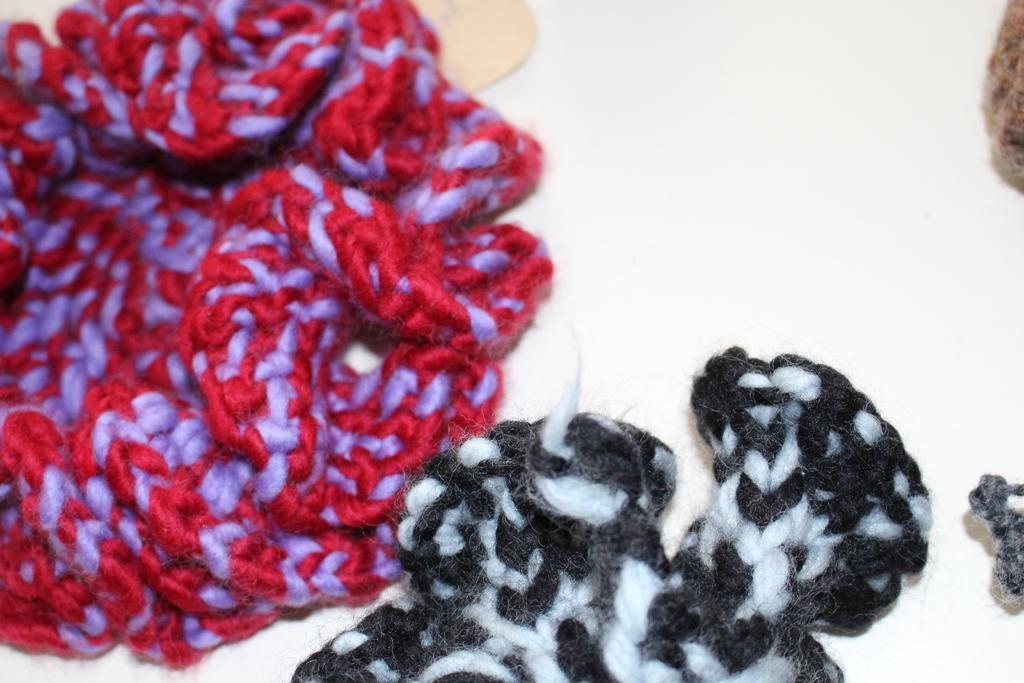Can you describe this image briefly? In this image I can see the white colored surface and on the surface I can see few threads which are red, violet, black, white and brown in color. 